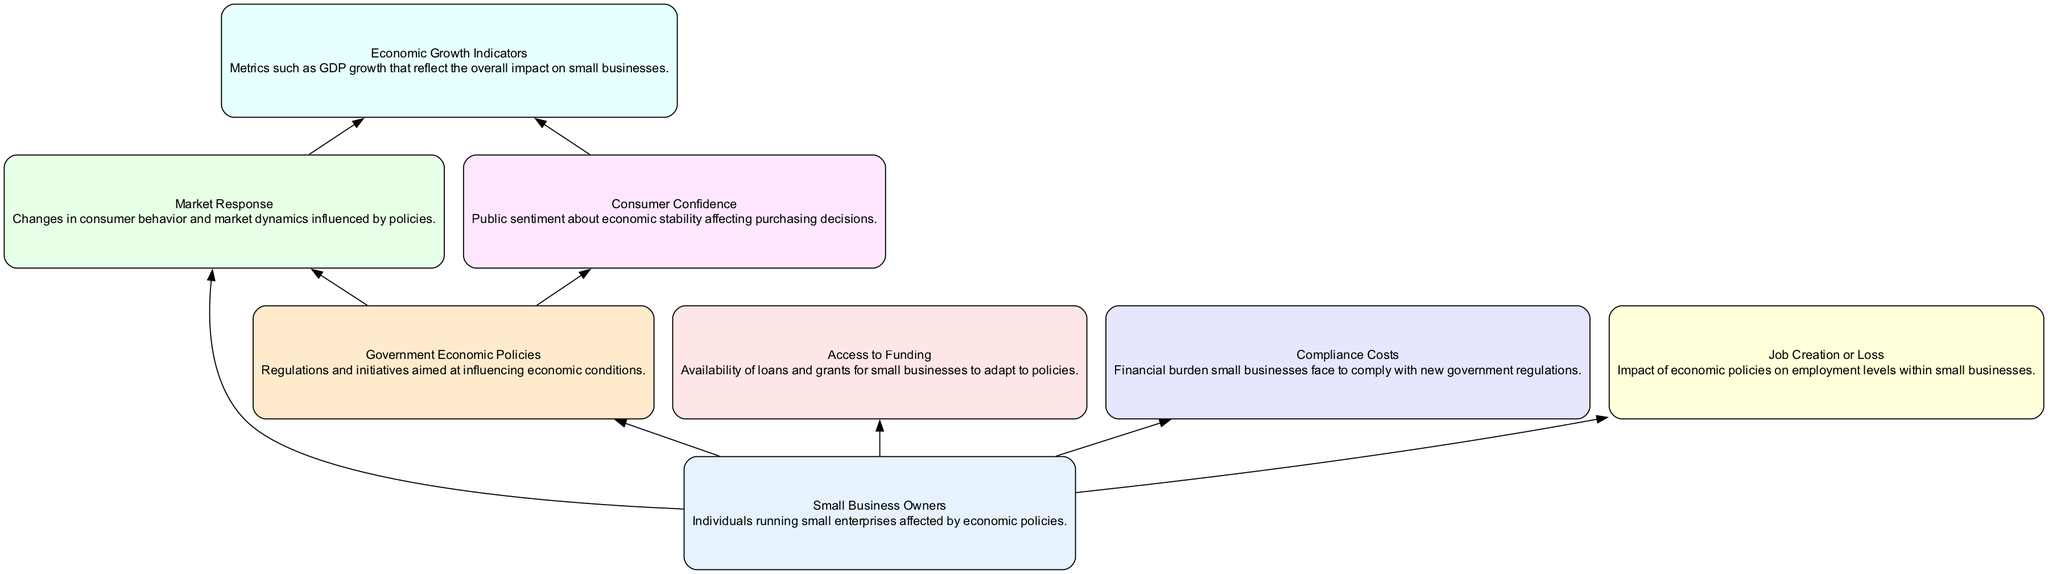What are the elements that small business owners are affected by? In the diagram, small business owners are influenced by various elements such as government economic policies, market response, access to funding, compliance costs, and job creation or loss. These elements directly surround the "Small Business Owners" node and indicate their relationship with it.
Answer: Government economic policies, Market response, Access to funding, Compliance costs, Job creation or loss How many total elements are in the diagram? The diagram lists eight distinct elements. By counting each unique block present in the diagram, we find that there are eight: Small Business Owners, Government Economic Policies, Market Response, Access to Funding, Compliance Costs, Job Creation or Loss, Consumer Confidence, and Economic Growth Indicators.
Answer: Eight Which element influences consumer confidence? The diagram indicates that government economic policies directly influence consumer confidence. There is a directed edge from "Government Economic Policies" to "Consumer Confidence" which means that changes in policies can affect public sentiment about economic stability.
Answer: Government economic policies What is the relationship between market response and economic growth indicators? The diagram shows that market response influences economic growth indicators. The directed edge leads from "Market Response" to "Economic Growth Indicators," indicating that changes in the market can reflect metrics such as GDP growth, affecting small businesses.
Answer: Market response What element has the most relationships illustrated in the diagram? By analyzing the edges, "Small Business Owners" has the most connections with five directed relationships leading out to other elements such as Government Economic Policies, Market Response, Access to Funding, Compliance Costs, and Job Creation or Loss.
Answer: Small Business Owners How many edges are connecting the nodes in the diagram? Counting the edges present in the diagram, which represent the relationships between the elements, we find a total of eight edges connecting the nodes: five from "Small Business Owners" and three connecting other relationships.
Answer: Eight Which element is most likely to indicate economic activity? The element that most directly indicates economic activity within the diagram is "Economic Growth Indicators," as it represents metrics like GDP which reflect the health and performance of small businesses within the economy.
Answer: Economic Growth Indicators What is the role of access to funding in relation to small business owners? Access to funding plays a supportive role for small business owners as it allows them to adapt and grow in response to government policies and market changes. This is illustrated by a direct edge from "Small Business Owners" to "Access to Funding."
Answer: Supportive role 